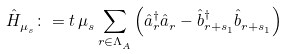<formula> <loc_0><loc_0><loc_500><loc_500>\hat { H } ^ { \ } _ { \mu ^ { \ } _ { s } } \colon = t \, \mu ^ { \ } _ { s } \sum _ { r \in \Lambda ^ { \ } _ { A } } \left ( \hat { a } ^ { \dag } _ { r } \hat { a } ^ { \ } _ { r } - \hat { b } ^ { \dag } _ { r + s ^ { \ } _ { 1 } } \hat { b } ^ { \ } _ { r + s ^ { \ } _ { 1 } } \right )</formula> 